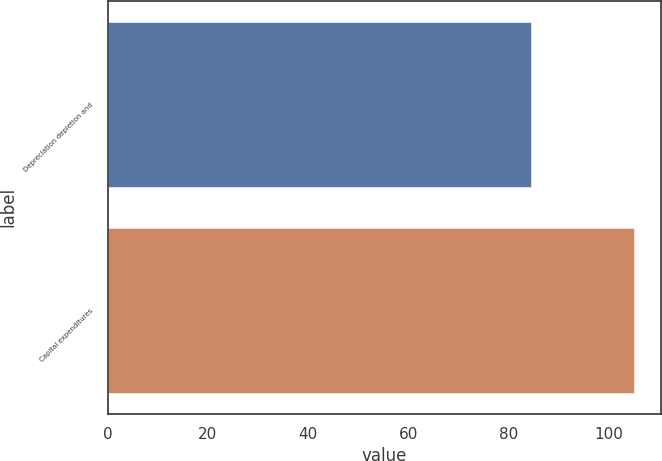Convert chart. <chart><loc_0><loc_0><loc_500><loc_500><bar_chart><fcel>Depreciation depletion and<fcel>Capital expenditures<nl><fcel>84.5<fcel>105.1<nl></chart> 